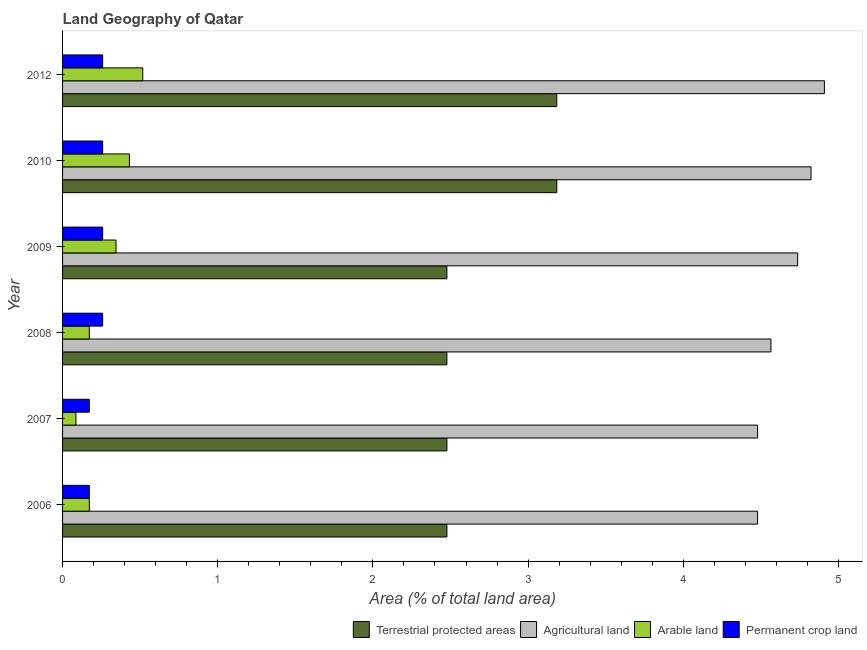Are the number of bars on each tick of the Y-axis equal?
Make the answer very short. Yes. What is the label of the 4th group of bars from the top?
Provide a short and direct response. 2008. In how many cases, is the number of bars for a given year not equal to the number of legend labels?
Provide a short and direct response. 0. What is the percentage of area under agricultural land in 2007?
Give a very brief answer. 4.48. Across all years, what is the maximum percentage of area under arable land?
Ensure brevity in your answer.  0.52. Across all years, what is the minimum percentage of area under arable land?
Your response must be concise. 0.09. In which year was the percentage of land under terrestrial protection maximum?
Your answer should be very brief. 2010. In which year was the percentage of area under agricultural land minimum?
Make the answer very short. 2006. What is the total percentage of area under permanent crop land in the graph?
Offer a terse response. 1.38. What is the difference between the percentage of area under permanent crop land in 2010 and the percentage of area under agricultural land in 2008?
Offer a very short reply. -4.31. What is the average percentage of area under agricultural land per year?
Your response must be concise. 4.67. In the year 2008, what is the difference between the percentage of area under permanent crop land and percentage of area under arable land?
Give a very brief answer. 0.09. What is the ratio of the percentage of area under permanent crop land in 2006 to that in 2010?
Make the answer very short. 0.67. Is the difference between the percentage of area under permanent crop land in 2007 and 2010 greater than the difference between the percentage of land under terrestrial protection in 2007 and 2010?
Offer a terse response. Yes. What is the difference between the highest and the second highest percentage of area under arable land?
Provide a short and direct response. 0.09. What is the difference between the highest and the lowest percentage of area under agricultural land?
Provide a succinct answer. 0.43. In how many years, is the percentage of area under permanent crop land greater than the average percentage of area under permanent crop land taken over all years?
Your response must be concise. 4. Is it the case that in every year, the sum of the percentage of area under agricultural land and percentage of area under arable land is greater than the sum of percentage of land under terrestrial protection and percentage of area under permanent crop land?
Give a very brief answer. No. What does the 3rd bar from the top in 2007 represents?
Offer a very short reply. Agricultural land. What does the 3rd bar from the bottom in 2012 represents?
Provide a succinct answer. Arable land. Are all the bars in the graph horizontal?
Keep it short and to the point. Yes. What is the difference between two consecutive major ticks on the X-axis?
Give a very brief answer. 1. Does the graph contain grids?
Make the answer very short. No. What is the title of the graph?
Offer a terse response. Land Geography of Qatar. What is the label or title of the X-axis?
Give a very brief answer. Area (% of total land area). What is the Area (% of total land area) in Terrestrial protected areas in 2006?
Make the answer very short. 2.48. What is the Area (% of total land area) of Agricultural land in 2006?
Make the answer very short. 4.48. What is the Area (% of total land area) in Arable land in 2006?
Ensure brevity in your answer.  0.17. What is the Area (% of total land area) of Permanent crop land in 2006?
Your answer should be very brief. 0.17. What is the Area (% of total land area) in Terrestrial protected areas in 2007?
Provide a succinct answer. 2.48. What is the Area (% of total land area) of Agricultural land in 2007?
Provide a short and direct response. 4.48. What is the Area (% of total land area) in Arable land in 2007?
Offer a terse response. 0.09. What is the Area (% of total land area) of Permanent crop land in 2007?
Offer a terse response. 0.17. What is the Area (% of total land area) of Terrestrial protected areas in 2008?
Your answer should be very brief. 2.48. What is the Area (% of total land area) of Agricultural land in 2008?
Give a very brief answer. 4.57. What is the Area (% of total land area) in Arable land in 2008?
Provide a short and direct response. 0.17. What is the Area (% of total land area) of Permanent crop land in 2008?
Give a very brief answer. 0.26. What is the Area (% of total land area) in Terrestrial protected areas in 2009?
Provide a short and direct response. 2.48. What is the Area (% of total land area) of Agricultural land in 2009?
Your answer should be compact. 4.74. What is the Area (% of total land area) in Arable land in 2009?
Make the answer very short. 0.34. What is the Area (% of total land area) of Permanent crop land in 2009?
Your response must be concise. 0.26. What is the Area (% of total land area) of Terrestrial protected areas in 2010?
Provide a succinct answer. 3.18. What is the Area (% of total land area) of Agricultural land in 2010?
Keep it short and to the point. 4.82. What is the Area (% of total land area) in Arable land in 2010?
Keep it short and to the point. 0.43. What is the Area (% of total land area) in Permanent crop land in 2010?
Your answer should be very brief. 0.26. What is the Area (% of total land area) of Terrestrial protected areas in 2012?
Your answer should be compact. 3.18. What is the Area (% of total land area) of Agricultural land in 2012?
Your response must be concise. 4.91. What is the Area (% of total land area) in Arable land in 2012?
Offer a very short reply. 0.52. What is the Area (% of total land area) of Permanent crop land in 2012?
Keep it short and to the point. 0.26. Across all years, what is the maximum Area (% of total land area) of Terrestrial protected areas?
Your answer should be compact. 3.18. Across all years, what is the maximum Area (% of total land area) of Agricultural land?
Offer a very short reply. 4.91. Across all years, what is the maximum Area (% of total land area) of Arable land?
Provide a short and direct response. 0.52. Across all years, what is the maximum Area (% of total land area) of Permanent crop land?
Your answer should be very brief. 0.26. Across all years, what is the minimum Area (% of total land area) of Terrestrial protected areas?
Your response must be concise. 2.48. Across all years, what is the minimum Area (% of total land area) in Agricultural land?
Keep it short and to the point. 4.48. Across all years, what is the minimum Area (% of total land area) in Arable land?
Your answer should be compact. 0.09. Across all years, what is the minimum Area (% of total land area) of Permanent crop land?
Provide a succinct answer. 0.17. What is the total Area (% of total land area) in Terrestrial protected areas in the graph?
Make the answer very short. 16.28. What is the total Area (% of total land area) in Agricultural land in the graph?
Your answer should be compact. 27.99. What is the total Area (% of total land area) in Arable land in the graph?
Make the answer very short. 1.72. What is the total Area (% of total land area) in Permanent crop land in the graph?
Give a very brief answer. 1.38. What is the difference between the Area (% of total land area) of Agricultural land in 2006 and that in 2007?
Give a very brief answer. 0. What is the difference between the Area (% of total land area) in Arable land in 2006 and that in 2007?
Your response must be concise. 0.09. What is the difference between the Area (% of total land area) of Agricultural land in 2006 and that in 2008?
Offer a very short reply. -0.09. What is the difference between the Area (% of total land area) of Permanent crop land in 2006 and that in 2008?
Provide a short and direct response. -0.09. What is the difference between the Area (% of total land area) of Agricultural land in 2006 and that in 2009?
Keep it short and to the point. -0.26. What is the difference between the Area (% of total land area) of Arable land in 2006 and that in 2009?
Provide a succinct answer. -0.17. What is the difference between the Area (% of total land area) in Permanent crop land in 2006 and that in 2009?
Offer a terse response. -0.09. What is the difference between the Area (% of total land area) in Terrestrial protected areas in 2006 and that in 2010?
Offer a very short reply. -0.71. What is the difference between the Area (% of total land area) of Agricultural land in 2006 and that in 2010?
Your answer should be compact. -0.34. What is the difference between the Area (% of total land area) in Arable land in 2006 and that in 2010?
Offer a terse response. -0.26. What is the difference between the Area (% of total land area) in Permanent crop land in 2006 and that in 2010?
Ensure brevity in your answer.  -0.09. What is the difference between the Area (% of total land area) in Terrestrial protected areas in 2006 and that in 2012?
Offer a very short reply. -0.71. What is the difference between the Area (% of total land area) in Agricultural land in 2006 and that in 2012?
Your response must be concise. -0.43. What is the difference between the Area (% of total land area) in Arable land in 2006 and that in 2012?
Your response must be concise. -0.34. What is the difference between the Area (% of total land area) of Permanent crop land in 2006 and that in 2012?
Provide a succinct answer. -0.09. What is the difference between the Area (% of total land area) of Agricultural land in 2007 and that in 2008?
Keep it short and to the point. -0.09. What is the difference between the Area (% of total land area) of Arable land in 2007 and that in 2008?
Your response must be concise. -0.09. What is the difference between the Area (% of total land area) in Permanent crop land in 2007 and that in 2008?
Ensure brevity in your answer.  -0.09. What is the difference between the Area (% of total land area) of Agricultural land in 2007 and that in 2009?
Make the answer very short. -0.26. What is the difference between the Area (% of total land area) in Arable land in 2007 and that in 2009?
Give a very brief answer. -0.26. What is the difference between the Area (% of total land area) of Permanent crop land in 2007 and that in 2009?
Ensure brevity in your answer.  -0.09. What is the difference between the Area (% of total land area) of Terrestrial protected areas in 2007 and that in 2010?
Keep it short and to the point. -0.71. What is the difference between the Area (% of total land area) of Agricultural land in 2007 and that in 2010?
Your answer should be compact. -0.34. What is the difference between the Area (% of total land area) of Arable land in 2007 and that in 2010?
Keep it short and to the point. -0.34. What is the difference between the Area (% of total land area) of Permanent crop land in 2007 and that in 2010?
Offer a very short reply. -0.09. What is the difference between the Area (% of total land area) in Terrestrial protected areas in 2007 and that in 2012?
Your answer should be very brief. -0.71. What is the difference between the Area (% of total land area) in Agricultural land in 2007 and that in 2012?
Keep it short and to the point. -0.43. What is the difference between the Area (% of total land area) of Arable land in 2007 and that in 2012?
Offer a very short reply. -0.43. What is the difference between the Area (% of total land area) of Permanent crop land in 2007 and that in 2012?
Keep it short and to the point. -0.09. What is the difference between the Area (% of total land area) in Terrestrial protected areas in 2008 and that in 2009?
Offer a very short reply. 0. What is the difference between the Area (% of total land area) in Agricultural land in 2008 and that in 2009?
Offer a terse response. -0.17. What is the difference between the Area (% of total land area) in Arable land in 2008 and that in 2009?
Give a very brief answer. -0.17. What is the difference between the Area (% of total land area) in Permanent crop land in 2008 and that in 2009?
Offer a very short reply. 0. What is the difference between the Area (% of total land area) of Terrestrial protected areas in 2008 and that in 2010?
Ensure brevity in your answer.  -0.71. What is the difference between the Area (% of total land area) of Agricultural land in 2008 and that in 2010?
Offer a very short reply. -0.26. What is the difference between the Area (% of total land area) in Arable land in 2008 and that in 2010?
Provide a succinct answer. -0.26. What is the difference between the Area (% of total land area) of Terrestrial protected areas in 2008 and that in 2012?
Your answer should be very brief. -0.71. What is the difference between the Area (% of total land area) of Agricultural land in 2008 and that in 2012?
Give a very brief answer. -0.34. What is the difference between the Area (% of total land area) in Arable land in 2008 and that in 2012?
Provide a succinct answer. -0.34. What is the difference between the Area (% of total land area) of Terrestrial protected areas in 2009 and that in 2010?
Your answer should be compact. -0.71. What is the difference between the Area (% of total land area) in Agricultural land in 2009 and that in 2010?
Offer a very short reply. -0.09. What is the difference between the Area (% of total land area) in Arable land in 2009 and that in 2010?
Your response must be concise. -0.09. What is the difference between the Area (% of total land area) of Permanent crop land in 2009 and that in 2010?
Your answer should be very brief. 0. What is the difference between the Area (% of total land area) of Terrestrial protected areas in 2009 and that in 2012?
Offer a terse response. -0.71. What is the difference between the Area (% of total land area) in Agricultural land in 2009 and that in 2012?
Your response must be concise. -0.17. What is the difference between the Area (% of total land area) in Arable land in 2009 and that in 2012?
Make the answer very short. -0.17. What is the difference between the Area (% of total land area) in Permanent crop land in 2009 and that in 2012?
Give a very brief answer. 0. What is the difference between the Area (% of total land area) of Terrestrial protected areas in 2010 and that in 2012?
Give a very brief answer. 0. What is the difference between the Area (% of total land area) in Agricultural land in 2010 and that in 2012?
Make the answer very short. -0.09. What is the difference between the Area (% of total land area) in Arable land in 2010 and that in 2012?
Provide a succinct answer. -0.09. What is the difference between the Area (% of total land area) of Permanent crop land in 2010 and that in 2012?
Provide a succinct answer. 0. What is the difference between the Area (% of total land area) in Terrestrial protected areas in 2006 and the Area (% of total land area) in Agricultural land in 2007?
Offer a very short reply. -2. What is the difference between the Area (% of total land area) in Terrestrial protected areas in 2006 and the Area (% of total land area) in Arable land in 2007?
Offer a terse response. 2.39. What is the difference between the Area (% of total land area) of Terrestrial protected areas in 2006 and the Area (% of total land area) of Permanent crop land in 2007?
Ensure brevity in your answer.  2.3. What is the difference between the Area (% of total land area) of Agricultural land in 2006 and the Area (% of total land area) of Arable land in 2007?
Keep it short and to the point. 4.39. What is the difference between the Area (% of total land area) in Agricultural land in 2006 and the Area (% of total land area) in Permanent crop land in 2007?
Keep it short and to the point. 4.31. What is the difference between the Area (% of total land area) of Arable land in 2006 and the Area (% of total land area) of Permanent crop land in 2007?
Keep it short and to the point. 0. What is the difference between the Area (% of total land area) of Terrestrial protected areas in 2006 and the Area (% of total land area) of Agricultural land in 2008?
Your answer should be compact. -2.09. What is the difference between the Area (% of total land area) in Terrestrial protected areas in 2006 and the Area (% of total land area) in Arable land in 2008?
Provide a succinct answer. 2.3. What is the difference between the Area (% of total land area) in Terrestrial protected areas in 2006 and the Area (% of total land area) in Permanent crop land in 2008?
Offer a very short reply. 2.22. What is the difference between the Area (% of total land area) in Agricultural land in 2006 and the Area (% of total land area) in Arable land in 2008?
Your response must be concise. 4.31. What is the difference between the Area (% of total land area) in Agricultural land in 2006 and the Area (% of total land area) in Permanent crop land in 2008?
Keep it short and to the point. 4.22. What is the difference between the Area (% of total land area) of Arable land in 2006 and the Area (% of total land area) of Permanent crop land in 2008?
Make the answer very short. -0.09. What is the difference between the Area (% of total land area) in Terrestrial protected areas in 2006 and the Area (% of total land area) in Agricultural land in 2009?
Your answer should be very brief. -2.26. What is the difference between the Area (% of total land area) in Terrestrial protected areas in 2006 and the Area (% of total land area) in Arable land in 2009?
Your response must be concise. 2.13. What is the difference between the Area (% of total land area) in Terrestrial protected areas in 2006 and the Area (% of total land area) in Permanent crop land in 2009?
Your response must be concise. 2.22. What is the difference between the Area (% of total land area) of Agricultural land in 2006 and the Area (% of total land area) of Arable land in 2009?
Offer a terse response. 4.13. What is the difference between the Area (% of total land area) in Agricultural land in 2006 and the Area (% of total land area) in Permanent crop land in 2009?
Offer a terse response. 4.22. What is the difference between the Area (% of total land area) of Arable land in 2006 and the Area (% of total land area) of Permanent crop land in 2009?
Offer a very short reply. -0.09. What is the difference between the Area (% of total land area) in Terrestrial protected areas in 2006 and the Area (% of total land area) in Agricultural land in 2010?
Offer a terse response. -2.35. What is the difference between the Area (% of total land area) of Terrestrial protected areas in 2006 and the Area (% of total land area) of Arable land in 2010?
Provide a short and direct response. 2.05. What is the difference between the Area (% of total land area) in Terrestrial protected areas in 2006 and the Area (% of total land area) in Permanent crop land in 2010?
Your answer should be compact. 2.22. What is the difference between the Area (% of total land area) in Agricultural land in 2006 and the Area (% of total land area) in Arable land in 2010?
Give a very brief answer. 4.05. What is the difference between the Area (% of total land area) in Agricultural land in 2006 and the Area (% of total land area) in Permanent crop land in 2010?
Ensure brevity in your answer.  4.22. What is the difference between the Area (% of total land area) in Arable land in 2006 and the Area (% of total land area) in Permanent crop land in 2010?
Ensure brevity in your answer.  -0.09. What is the difference between the Area (% of total land area) in Terrestrial protected areas in 2006 and the Area (% of total land area) in Agricultural land in 2012?
Offer a very short reply. -2.43. What is the difference between the Area (% of total land area) of Terrestrial protected areas in 2006 and the Area (% of total land area) of Arable land in 2012?
Offer a terse response. 1.96. What is the difference between the Area (% of total land area) in Terrestrial protected areas in 2006 and the Area (% of total land area) in Permanent crop land in 2012?
Your response must be concise. 2.22. What is the difference between the Area (% of total land area) of Agricultural land in 2006 and the Area (% of total land area) of Arable land in 2012?
Give a very brief answer. 3.96. What is the difference between the Area (% of total land area) in Agricultural land in 2006 and the Area (% of total land area) in Permanent crop land in 2012?
Provide a short and direct response. 4.22. What is the difference between the Area (% of total land area) in Arable land in 2006 and the Area (% of total land area) in Permanent crop land in 2012?
Ensure brevity in your answer.  -0.09. What is the difference between the Area (% of total land area) of Terrestrial protected areas in 2007 and the Area (% of total land area) of Agricultural land in 2008?
Offer a terse response. -2.09. What is the difference between the Area (% of total land area) of Terrestrial protected areas in 2007 and the Area (% of total land area) of Arable land in 2008?
Your answer should be compact. 2.3. What is the difference between the Area (% of total land area) of Terrestrial protected areas in 2007 and the Area (% of total land area) of Permanent crop land in 2008?
Ensure brevity in your answer.  2.22. What is the difference between the Area (% of total land area) in Agricultural land in 2007 and the Area (% of total land area) in Arable land in 2008?
Make the answer very short. 4.31. What is the difference between the Area (% of total land area) of Agricultural land in 2007 and the Area (% of total land area) of Permanent crop land in 2008?
Provide a short and direct response. 4.22. What is the difference between the Area (% of total land area) in Arable land in 2007 and the Area (% of total land area) in Permanent crop land in 2008?
Give a very brief answer. -0.17. What is the difference between the Area (% of total land area) in Terrestrial protected areas in 2007 and the Area (% of total land area) in Agricultural land in 2009?
Offer a terse response. -2.26. What is the difference between the Area (% of total land area) in Terrestrial protected areas in 2007 and the Area (% of total land area) in Arable land in 2009?
Keep it short and to the point. 2.13. What is the difference between the Area (% of total land area) in Terrestrial protected areas in 2007 and the Area (% of total land area) in Permanent crop land in 2009?
Your answer should be compact. 2.22. What is the difference between the Area (% of total land area) in Agricultural land in 2007 and the Area (% of total land area) in Arable land in 2009?
Your response must be concise. 4.13. What is the difference between the Area (% of total land area) in Agricultural land in 2007 and the Area (% of total land area) in Permanent crop land in 2009?
Offer a terse response. 4.22. What is the difference between the Area (% of total land area) in Arable land in 2007 and the Area (% of total land area) in Permanent crop land in 2009?
Your response must be concise. -0.17. What is the difference between the Area (% of total land area) in Terrestrial protected areas in 2007 and the Area (% of total land area) in Agricultural land in 2010?
Offer a terse response. -2.35. What is the difference between the Area (% of total land area) in Terrestrial protected areas in 2007 and the Area (% of total land area) in Arable land in 2010?
Provide a short and direct response. 2.05. What is the difference between the Area (% of total land area) of Terrestrial protected areas in 2007 and the Area (% of total land area) of Permanent crop land in 2010?
Provide a succinct answer. 2.22. What is the difference between the Area (% of total land area) in Agricultural land in 2007 and the Area (% of total land area) in Arable land in 2010?
Provide a short and direct response. 4.05. What is the difference between the Area (% of total land area) in Agricultural land in 2007 and the Area (% of total land area) in Permanent crop land in 2010?
Your response must be concise. 4.22. What is the difference between the Area (% of total land area) of Arable land in 2007 and the Area (% of total land area) of Permanent crop land in 2010?
Your answer should be very brief. -0.17. What is the difference between the Area (% of total land area) of Terrestrial protected areas in 2007 and the Area (% of total land area) of Agricultural land in 2012?
Provide a short and direct response. -2.43. What is the difference between the Area (% of total land area) in Terrestrial protected areas in 2007 and the Area (% of total land area) in Arable land in 2012?
Offer a terse response. 1.96. What is the difference between the Area (% of total land area) in Terrestrial protected areas in 2007 and the Area (% of total land area) in Permanent crop land in 2012?
Ensure brevity in your answer.  2.22. What is the difference between the Area (% of total land area) in Agricultural land in 2007 and the Area (% of total land area) in Arable land in 2012?
Offer a very short reply. 3.96. What is the difference between the Area (% of total land area) in Agricultural land in 2007 and the Area (% of total land area) in Permanent crop land in 2012?
Give a very brief answer. 4.22. What is the difference between the Area (% of total land area) of Arable land in 2007 and the Area (% of total land area) of Permanent crop land in 2012?
Give a very brief answer. -0.17. What is the difference between the Area (% of total land area) of Terrestrial protected areas in 2008 and the Area (% of total land area) of Agricultural land in 2009?
Keep it short and to the point. -2.26. What is the difference between the Area (% of total land area) of Terrestrial protected areas in 2008 and the Area (% of total land area) of Arable land in 2009?
Ensure brevity in your answer.  2.13. What is the difference between the Area (% of total land area) in Terrestrial protected areas in 2008 and the Area (% of total land area) in Permanent crop land in 2009?
Your answer should be compact. 2.22. What is the difference between the Area (% of total land area) in Agricultural land in 2008 and the Area (% of total land area) in Arable land in 2009?
Your answer should be very brief. 4.22. What is the difference between the Area (% of total land area) in Agricultural land in 2008 and the Area (% of total land area) in Permanent crop land in 2009?
Provide a short and direct response. 4.31. What is the difference between the Area (% of total land area) in Arable land in 2008 and the Area (% of total land area) in Permanent crop land in 2009?
Offer a terse response. -0.09. What is the difference between the Area (% of total land area) of Terrestrial protected areas in 2008 and the Area (% of total land area) of Agricultural land in 2010?
Give a very brief answer. -2.35. What is the difference between the Area (% of total land area) in Terrestrial protected areas in 2008 and the Area (% of total land area) in Arable land in 2010?
Provide a succinct answer. 2.05. What is the difference between the Area (% of total land area) of Terrestrial protected areas in 2008 and the Area (% of total land area) of Permanent crop land in 2010?
Give a very brief answer. 2.22. What is the difference between the Area (% of total land area) in Agricultural land in 2008 and the Area (% of total land area) in Arable land in 2010?
Your answer should be very brief. 4.13. What is the difference between the Area (% of total land area) in Agricultural land in 2008 and the Area (% of total land area) in Permanent crop land in 2010?
Keep it short and to the point. 4.31. What is the difference between the Area (% of total land area) in Arable land in 2008 and the Area (% of total land area) in Permanent crop land in 2010?
Your answer should be very brief. -0.09. What is the difference between the Area (% of total land area) in Terrestrial protected areas in 2008 and the Area (% of total land area) in Agricultural land in 2012?
Your response must be concise. -2.43. What is the difference between the Area (% of total land area) in Terrestrial protected areas in 2008 and the Area (% of total land area) in Arable land in 2012?
Keep it short and to the point. 1.96. What is the difference between the Area (% of total land area) of Terrestrial protected areas in 2008 and the Area (% of total land area) of Permanent crop land in 2012?
Provide a succinct answer. 2.22. What is the difference between the Area (% of total land area) of Agricultural land in 2008 and the Area (% of total land area) of Arable land in 2012?
Your answer should be compact. 4.05. What is the difference between the Area (% of total land area) of Agricultural land in 2008 and the Area (% of total land area) of Permanent crop land in 2012?
Offer a very short reply. 4.31. What is the difference between the Area (% of total land area) of Arable land in 2008 and the Area (% of total land area) of Permanent crop land in 2012?
Give a very brief answer. -0.09. What is the difference between the Area (% of total land area) of Terrestrial protected areas in 2009 and the Area (% of total land area) of Agricultural land in 2010?
Your response must be concise. -2.35. What is the difference between the Area (% of total land area) in Terrestrial protected areas in 2009 and the Area (% of total land area) in Arable land in 2010?
Ensure brevity in your answer.  2.05. What is the difference between the Area (% of total land area) in Terrestrial protected areas in 2009 and the Area (% of total land area) in Permanent crop land in 2010?
Keep it short and to the point. 2.22. What is the difference between the Area (% of total land area) in Agricultural land in 2009 and the Area (% of total land area) in Arable land in 2010?
Offer a very short reply. 4.31. What is the difference between the Area (% of total land area) in Agricultural land in 2009 and the Area (% of total land area) in Permanent crop land in 2010?
Your answer should be compact. 4.48. What is the difference between the Area (% of total land area) in Arable land in 2009 and the Area (% of total land area) in Permanent crop land in 2010?
Give a very brief answer. 0.09. What is the difference between the Area (% of total land area) of Terrestrial protected areas in 2009 and the Area (% of total land area) of Agricultural land in 2012?
Provide a short and direct response. -2.43. What is the difference between the Area (% of total land area) in Terrestrial protected areas in 2009 and the Area (% of total land area) in Arable land in 2012?
Offer a terse response. 1.96. What is the difference between the Area (% of total land area) in Terrestrial protected areas in 2009 and the Area (% of total land area) in Permanent crop land in 2012?
Your answer should be very brief. 2.22. What is the difference between the Area (% of total land area) of Agricultural land in 2009 and the Area (% of total land area) of Arable land in 2012?
Offer a terse response. 4.22. What is the difference between the Area (% of total land area) of Agricultural land in 2009 and the Area (% of total land area) of Permanent crop land in 2012?
Offer a very short reply. 4.48. What is the difference between the Area (% of total land area) in Arable land in 2009 and the Area (% of total land area) in Permanent crop land in 2012?
Offer a terse response. 0.09. What is the difference between the Area (% of total land area) of Terrestrial protected areas in 2010 and the Area (% of total land area) of Agricultural land in 2012?
Keep it short and to the point. -1.72. What is the difference between the Area (% of total land area) in Terrestrial protected areas in 2010 and the Area (% of total land area) in Arable land in 2012?
Offer a terse response. 2.67. What is the difference between the Area (% of total land area) in Terrestrial protected areas in 2010 and the Area (% of total land area) in Permanent crop land in 2012?
Make the answer very short. 2.93. What is the difference between the Area (% of total land area) in Agricultural land in 2010 and the Area (% of total land area) in Arable land in 2012?
Your answer should be very brief. 4.31. What is the difference between the Area (% of total land area) of Agricultural land in 2010 and the Area (% of total land area) of Permanent crop land in 2012?
Your answer should be very brief. 4.57. What is the difference between the Area (% of total land area) in Arable land in 2010 and the Area (% of total land area) in Permanent crop land in 2012?
Your response must be concise. 0.17. What is the average Area (% of total land area) in Terrestrial protected areas per year?
Keep it short and to the point. 2.71. What is the average Area (% of total land area) in Agricultural land per year?
Your response must be concise. 4.67. What is the average Area (% of total land area) of Arable land per year?
Offer a terse response. 0.29. What is the average Area (% of total land area) in Permanent crop land per year?
Provide a succinct answer. 0.23. In the year 2006, what is the difference between the Area (% of total land area) in Terrestrial protected areas and Area (% of total land area) in Agricultural land?
Keep it short and to the point. -2. In the year 2006, what is the difference between the Area (% of total land area) of Terrestrial protected areas and Area (% of total land area) of Arable land?
Ensure brevity in your answer.  2.3. In the year 2006, what is the difference between the Area (% of total land area) in Terrestrial protected areas and Area (% of total land area) in Permanent crop land?
Your answer should be very brief. 2.3. In the year 2006, what is the difference between the Area (% of total land area) of Agricultural land and Area (% of total land area) of Arable land?
Keep it short and to the point. 4.31. In the year 2006, what is the difference between the Area (% of total land area) in Agricultural land and Area (% of total land area) in Permanent crop land?
Give a very brief answer. 4.31. In the year 2006, what is the difference between the Area (% of total land area) of Arable land and Area (% of total land area) of Permanent crop land?
Keep it short and to the point. 0. In the year 2007, what is the difference between the Area (% of total land area) in Terrestrial protected areas and Area (% of total land area) in Agricultural land?
Offer a terse response. -2. In the year 2007, what is the difference between the Area (% of total land area) of Terrestrial protected areas and Area (% of total land area) of Arable land?
Give a very brief answer. 2.39. In the year 2007, what is the difference between the Area (% of total land area) in Terrestrial protected areas and Area (% of total land area) in Permanent crop land?
Your answer should be very brief. 2.3. In the year 2007, what is the difference between the Area (% of total land area) in Agricultural land and Area (% of total land area) in Arable land?
Keep it short and to the point. 4.39. In the year 2007, what is the difference between the Area (% of total land area) of Agricultural land and Area (% of total land area) of Permanent crop land?
Provide a succinct answer. 4.31. In the year 2007, what is the difference between the Area (% of total land area) in Arable land and Area (% of total land area) in Permanent crop land?
Provide a succinct answer. -0.09. In the year 2008, what is the difference between the Area (% of total land area) of Terrestrial protected areas and Area (% of total land area) of Agricultural land?
Offer a very short reply. -2.09. In the year 2008, what is the difference between the Area (% of total land area) of Terrestrial protected areas and Area (% of total land area) of Arable land?
Make the answer very short. 2.3. In the year 2008, what is the difference between the Area (% of total land area) in Terrestrial protected areas and Area (% of total land area) in Permanent crop land?
Offer a terse response. 2.22. In the year 2008, what is the difference between the Area (% of total land area) of Agricultural land and Area (% of total land area) of Arable land?
Provide a succinct answer. 4.39. In the year 2008, what is the difference between the Area (% of total land area) of Agricultural land and Area (% of total land area) of Permanent crop land?
Your response must be concise. 4.31. In the year 2008, what is the difference between the Area (% of total land area) of Arable land and Area (% of total land area) of Permanent crop land?
Your answer should be very brief. -0.09. In the year 2009, what is the difference between the Area (% of total land area) of Terrestrial protected areas and Area (% of total land area) of Agricultural land?
Your response must be concise. -2.26. In the year 2009, what is the difference between the Area (% of total land area) of Terrestrial protected areas and Area (% of total land area) of Arable land?
Keep it short and to the point. 2.13. In the year 2009, what is the difference between the Area (% of total land area) of Terrestrial protected areas and Area (% of total land area) of Permanent crop land?
Give a very brief answer. 2.22. In the year 2009, what is the difference between the Area (% of total land area) in Agricultural land and Area (% of total land area) in Arable land?
Provide a short and direct response. 4.39. In the year 2009, what is the difference between the Area (% of total land area) of Agricultural land and Area (% of total land area) of Permanent crop land?
Your answer should be compact. 4.48. In the year 2009, what is the difference between the Area (% of total land area) of Arable land and Area (% of total land area) of Permanent crop land?
Your response must be concise. 0.09. In the year 2010, what is the difference between the Area (% of total land area) in Terrestrial protected areas and Area (% of total land area) in Agricultural land?
Offer a very short reply. -1.64. In the year 2010, what is the difference between the Area (% of total land area) in Terrestrial protected areas and Area (% of total land area) in Arable land?
Your answer should be very brief. 2.75. In the year 2010, what is the difference between the Area (% of total land area) in Terrestrial protected areas and Area (% of total land area) in Permanent crop land?
Give a very brief answer. 2.93. In the year 2010, what is the difference between the Area (% of total land area) in Agricultural land and Area (% of total land area) in Arable land?
Offer a terse response. 4.39. In the year 2010, what is the difference between the Area (% of total land area) in Agricultural land and Area (% of total land area) in Permanent crop land?
Offer a very short reply. 4.57. In the year 2010, what is the difference between the Area (% of total land area) in Arable land and Area (% of total land area) in Permanent crop land?
Provide a short and direct response. 0.17. In the year 2012, what is the difference between the Area (% of total land area) of Terrestrial protected areas and Area (% of total land area) of Agricultural land?
Offer a terse response. -1.72. In the year 2012, what is the difference between the Area (% of total land area) of Terrestrial protected areas and Area (% of total land area) of Arable land?
Your answer should be compact. 2.67. In the year 2012, what is the difference between the Area (% of total land area) of Terrestrial protected areas and Area (% of total land area) of Permanent crop land?
Your answer should be compact. 2.93. In the year 2012, what is the difference between the Area (% of total land area) in Agricultural land and Area (% of total land area) in Arable land?
Give a very brief answer. 4.39. In the year 2012, what is the difference between the Area (% of total land area) of Agricultural land and Area (% of total land area) of Permanent crop land?
Your response must be concise. 4.65. In the year 2012, what is the difference between the Area (% of total land area) in Arable land and Area (% of total land area) in Permanent crop land?
Keep it short and to the point. 0.26. What is the ratio of the Area (% of total land area) in Terrestrial protected areas in 2006 to that in 2007?
Provide a short and direct response. 1. What is the ratio of the Area (% of total land area) of Arable land in 2006 to that in 2007?
Your response must be concise. 2. What is the ratio of the Area (% of total land area) in Agricultural land in 2006 to that in 2008?
Provide a succinct answer. 0.98. What is the ratio of the Area (% of total land area) of Permanent crop land in 2006 to that in 2008?
Keep it short and to the point. 0.67. What is the ratio of the Area (% of total land area) in Agricultural land in 2006 to that in 2009?
Provide a succinct answer. 0.95. What is the ratio of the Area (% of total land area) of Arable land in 2006 to that in 2009?
Give a very brief answer. 0.5. What is the ratio of the Area (% of total land area) of Terrestrial protected areas in 2006 to that in 2010?
Your answer should be compact. 0.78. What is the ratio of the Area (% of total land area) in Permanent crop land in 2006 to that in 2010?
Provide a succinct answer. 0.67. What is the ratio of the Area (% of total land area) of Terrestrial protected areas in 2006 to that in 2012?
Offer a terse response. 0.78. What is the ratio of the Area (% of total land area) of Agricultural land in 2006 to that in 2012?
Give a very brief answer. 0.91. What is the ratio of the Area (% of total land area) of Agricultural land in 2007 to that in 2008?
Give a very brief answer. 0.98. What is the ratio of the Area (% of total land area) of Arable land in 2007 to that in 2008?
Offer a terse response. 0.5. What is the ratio of the Area (% of total land area) in Agricultural land in 2007 to that in 2009?
Make the answer very short. 0.95. What is the ratio of the Area (% of total land area) of Permanent crop land in 2007 to that in 2009?
Ensure brevity in your answer.  0.67. What is the ratio of the Area (% of total land area) in Terrestrial protected areas in 2007 to that in 2010?
Ensure brevity in your answer.  0.78. What is the ratio of the Area (% of total land area) in Arable land in 2007 to that in 2010?
Offer a terse response. 0.2. What is the ratio of the Area (% of total land area) in Permanent crop land in 2007 to that in 2010?
Your answer should be very brief. 0.67. What is the ratio of the Area (% of total land area) in Terrestrial protected areas in 2007 to that in 2012?
Give a very brief answer. 0.78. What is the ratio of the Area (% of total land area) in Agricultural land in 2007 to that in 2012?
Your answer should be compact. 0.91. What is the ratio of the Area (% of total land area) of Arable land in 2007 to that in 2012?
Give a very brief answer. 0.17. What is the ratio of the Area (% of total land area) of Agricultural land in 2008 to that in 2009?
Make the answer very short. 0.96. What is the ratio of the Area (% of total land area) of Arable land in 2008 to that in 2009?
Your answer should be compact. 0.5. What is the ratio of the Area (% of total land area) of Permanent crop land in 2008 to that in 2009?
Provide a succinct answer. 1. What is the ratio of the Area (% of total land area) of Terrestrial protected areas in 2008 to that in 2010?
Ensure brevity in your answer.  0.78. What is the ratio of the Area (% of total land area) in Agricultural land in 2008 to that in 2010?
Your answer should be compact. 0.95. What is the ratio of the Area (% of total land area) in Permanent crop land in 2008 to that in 2010?
Make the answer very short. 1. What is the ratio of the Area (% of total land area) of Terrestrial protected areas in 2008 to that in 2012?
Your response must be concise. 0.78. What is the ratio of the Area (% of total land area) of Agricultural land in 2008 to that in 2012?
Ensure brevity in your answer.  0.93. What is the ratio of the Area (% of total land area) of Terrestrial protected areas in 2009 to that in 2010?
Provide a succinct answer. 0.78. What is the ratio of the Area (% of total land area) in Agricultural land in 2009 to that in 2010?
Your answer should be compact. 0.98. What is the ratio of the Area (% of total land area) in Terrestrial protected areas in 2009 to that in 2012?
Make the answer very short. 0.78. What is the ratio of the Area (% of total land area) of Agricultural land in 2009 to that in 2012?
Offer a terse response. 0.96. What is the ratio of the Area (% of total land area) of Agricultural land in 2010 to that in 2012?
Keep it short and to the point. 0.98. What is the ratio of the Area (% of total land area) of Permanent crop land in 2010 to that in 2012?
Provide a short and direct response. 1. What is the difference between the highest and the second highest Area (% of total land area) in Terrestrial protected areas?
Give a very brief answer. 0. What is the difference between the highest and the second highest Area (% of total land area) in Agricultural land?
Your response must be concise. 0.09. What is the difference between the highest and the second highest Area (% of total land area) in Arable land?
Your response must be concise. 0.09. What is the difference between the highest and the lowest Area (% of total land area) in Terrestrial protected areas?
Make the answer very short. 0.71. What is the difference between the highest and the lowest Area (% of total land area) in Agricultural land?
Offer a terse response. 0.43. What is the difference between the highest and the lowest Area (% of total land area) of Arable land?
Your response must be concise. 0.43. What is the difference between the highest and the lowest Area (% of total land area) of Permanent crop land?
Provide a short and direct response. 0.09. 